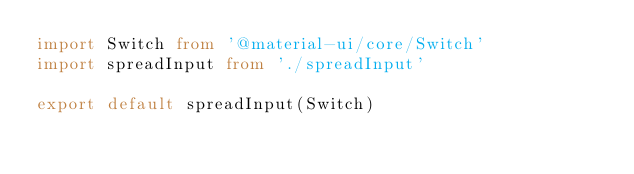Convert code to text. <code><loc_0><loc_0><loc_500><loc_500><_TypeScript_>import Switch from '@material-ui/core/Switch'
import spreadInput from './spreadInput'

export default spreadInput(Switch)
</code> 